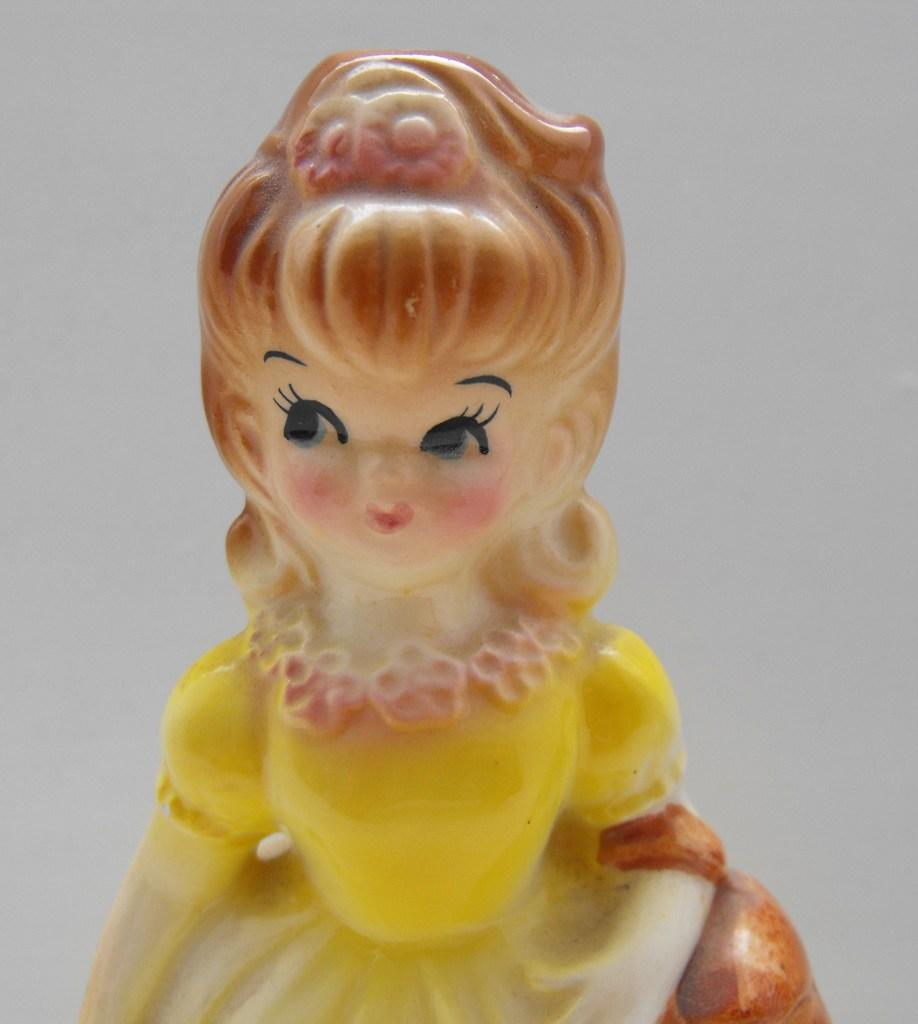What object can be seen in the image? There is a toy in the image. What type of bread is being used to support the toy in the image? There is no bread or support for the toy in the image; it is a standalone toy. 